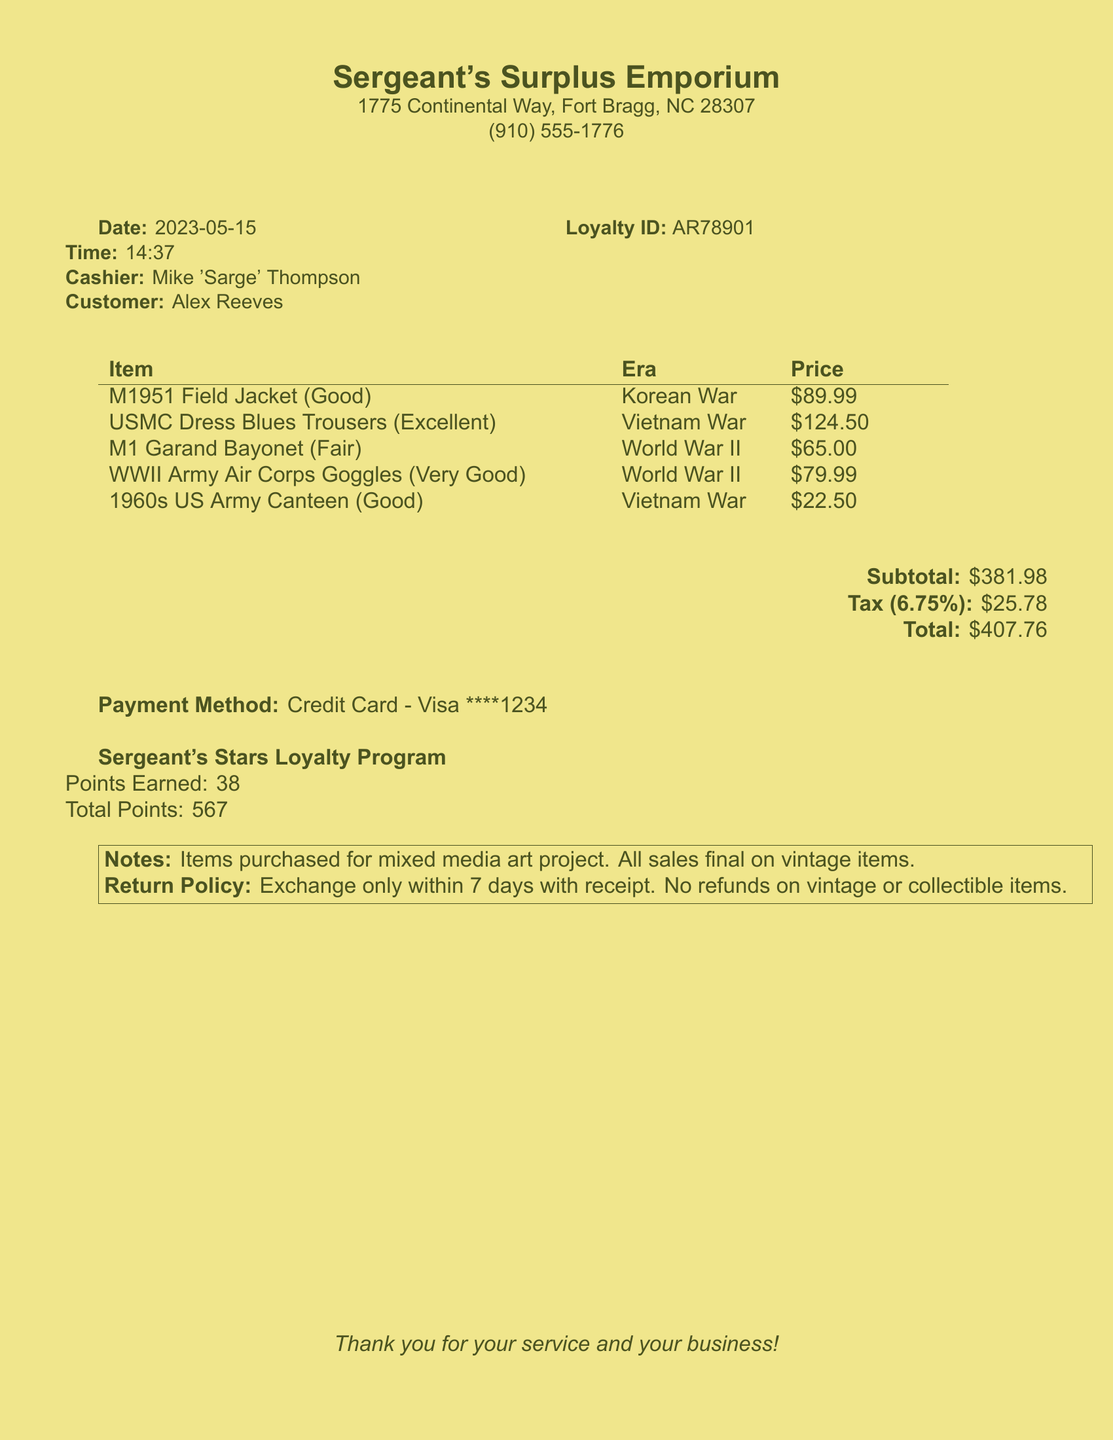What is the name of the store? The store name is located at the top of the document, indicating where the transaction took place.
Answer: Sergeant's Surplus Emporium What is the date of the transaction? The date is specified in the document, showing when the purchase was made.
Answer: 2023-05-15 Who was the cashier for this transaction? The cashier's name is mentioned alongside the date and time, indicating who assisted the customer.
Answer: Mike 'Sarge' Thompson What was the total amount paid? The total amount is clearly outlined towards the end of the receipt, summarizing the final charge.
Answer: $407.76 How many points were earned in the loyalty program? The points earned are tracked in the loyalty program section of the receipt.
Answer: 38 What is the era of the M1951 Field Jacket? The era of each item is specified in the receipt, providing historical context for the uniforms.
Answer: Korean War What is the return policy for vintage items? The return policy section explicitly outlines the terms related to item returns.
Answer: Exchange only within 7 days with receipt. No refunds on vintage or collectible items What condition is the USMC Dress Blues Trousers in? The condition of items is provided for each listed product in the receipt.
Answer: Excellent What payment method was used for this purchase? The payment method is mentioned towards the bottom of the receipt, indicating how the purchase was completed.
Answer: Credit Card - Visa ****1234 